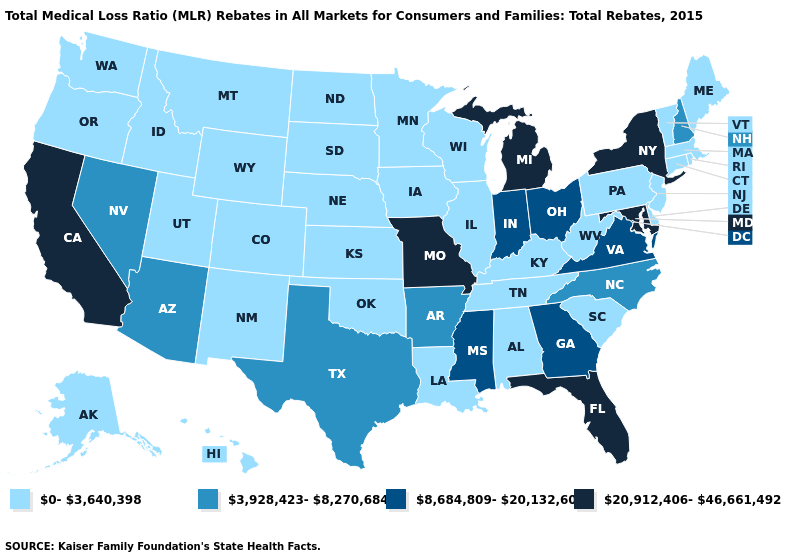Among the states that border New Jersey , which have the highest value?
Keep it brief. New York. What is the value of Missouri?
Give a very brief answer. 20,912,406-46,661,492. Among the states that border Maryland , which have the lowest value?
Write a very short answer. Delaware, Pennsylvania, West Virginia. Does the map have missing data?
Give a very brief answer. No. What is the value of South Carolina?
Keep it brief. 0-3,640,398. Name the states that have a value in the range 20,912,406-46,661,492?
Be succinct. California, Florida, Maryland, Michigan, Missouri, New York. Does Mississippi have a higher value than South Dakota?
Be succinct. Yes. What is the lowest value in the USA?
Quick response, please. 0-3,640,398. What is the value of Washington?
Quick response, please. 0-3,640,398. Does the map have missing data?
Quick response, please. No. What is the highest value in states that border Utah?
Give a very brief answer. 3,928,423-8,270,684. Name the states that have a value in the range 8,684,809-20,132,607?
Short answer required. Georgia, Indiana, Mississippi, Ohio, Virginia. Does the map have missing data?
Short answer required. No. Which states have the lowest value in the USA?
Be succinct. Alabama, Alaska, Colorado, Connecticut, Delaware, Hawaii, Idaho, Illinois, Iowa, Kansas, Kentucky, Louisiana, Maine, Massachusetts, Minnesota, Montana, Nebraska, New Jersey, New Mexico, North Dakota, Oklahoma, Oregon, Pennsylvania, Rhode Island, South Carolina, South Dakota, Tennessee, Utah, Vermont, Washington, West Virginia, Wisconsin, Wyoming. 